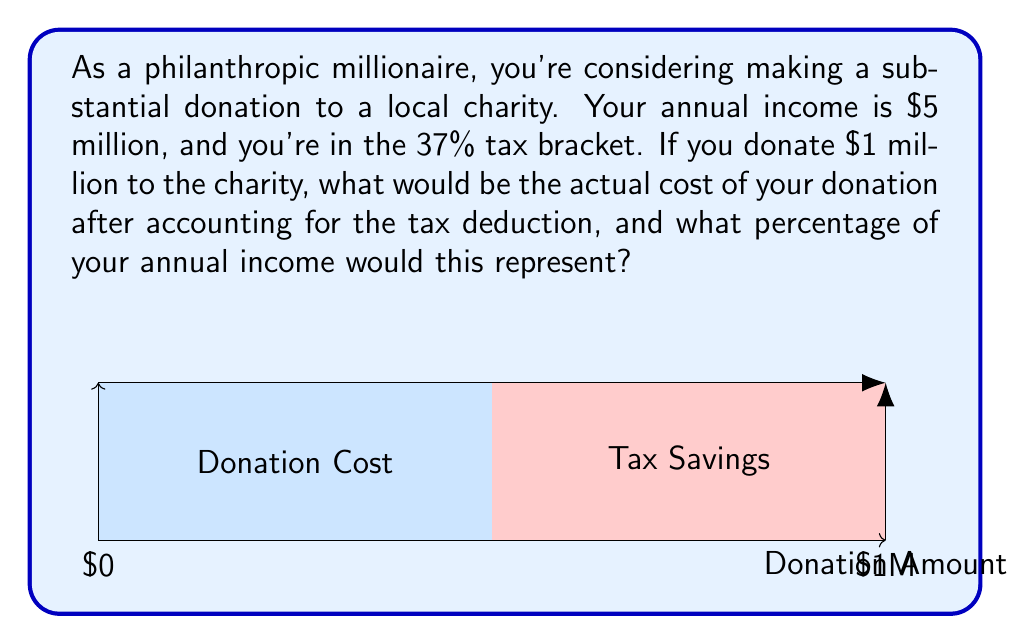Show me your answer to this math problem. Let's break this down step-by-step:

1) Your initial donation amount is $1 million.

2) The tax deduction works by reducing your taxable income by the amount of the donation. Since you're in the 37% tax bracket, this means you'll save 37% of the donation amount in taxes.

3) To calculate the tax savings:
   $$ \text{Tax Savings} = \text{Donation Amount} \times \text{Tax Rate} $$
   $$ \text{Tax Savings} = \$1,000,000 \times 0.37 = \$370,000 $$

4) The actual cost of your donation is the initial amount minus the tax savings:
   $$ \text{Actual Cost} = \text{Donation Amount} - \text{Tax Savings} $$
   $$ \text{Actual Cost} = \$1,000,000 - \$370,000 = \$630,000 $$

5) To calculate what percentage of your annual income this represents:
   $$ \text{Percentage} = \frac{\text{Actual Cost}}{\text{Annual Income}} \times 100\% $$
   $$ \text{Percentage} = \frac{\$630,000}{\$5,000,000} \times 100\% = 12.6\% $$

Therefore, the actual cost of your $1 million donation after tax deductions is $630,000, which represents 12.6% of your annual income.
Answer: $630,000; 12.6% 